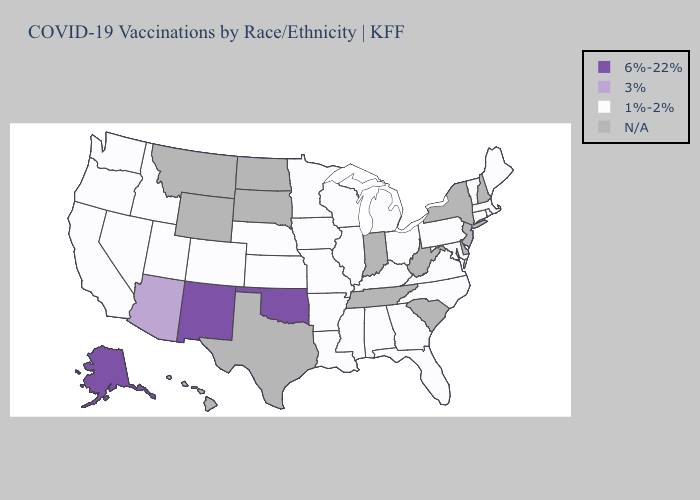What is the value of California?
Give a very brief answer. 1%-2%. Does Kansas have the highest value in the USA?
Keep it brief. No. What is the lowest value in the USA?
Short answer required. 1%-2%. Does New Mexico have the highest value in the USA?
Write a very short answer. Yes. Name the states that have a value in the range 1%-2%?
Quick response, please. Alabama, Arkansas, California, Colorado, Connecticut, Florida, Georgia, Idaho, Illinois, Iowa, Kansas, Kentucky, Louisiana, Maine, Maryland, Massachusetts, Michigan, Minnesota, Mississippi, Missouri, Nebraska, Nevada, North Carolina, Ohio, Oregon, Pennsylvania, Rhode Island, Utah, Vermont, Virginia, Washington, Wisconsin. Name the states that have a value in the range 3%?
Concise answer only. Arizona. What is the value of Hawaii?
Quick response, please. N/A. What is the lowest value in the West?
Concise answer only. 1%-2%. What is the value of Delaware?
Quick response, please. N/A. What is the lowest value in the USA?
Concise answer only. 1%-2%. What is the lowest value in states that border Illinois?
Give a very brief answer. 1%-2%. Which states have the highest value in the USA?
Be succinct. Alaska, New Mexico, Oklahoma. Name the states that have a value in the range 1%-2%?
Short answer required. Alabama, Arkansas, California, Colorado, Connecticut, Florida, Georgia, Idaho, Illinois, Iowa, Kansas, Kentucky, Louisiana, Maine, Maryland, Massachusetts, Michigan, Minnesota, Mississippi, Missouri, Nebraska, Nevada, North Carolina, Ohio, Oregon, Pennsylvania, Rhode Island, Utah, Vermont, Virginia, Washington, Wisconsin. What is the highest value in the MidWest ?
Concise answer only. 1%-2%. 